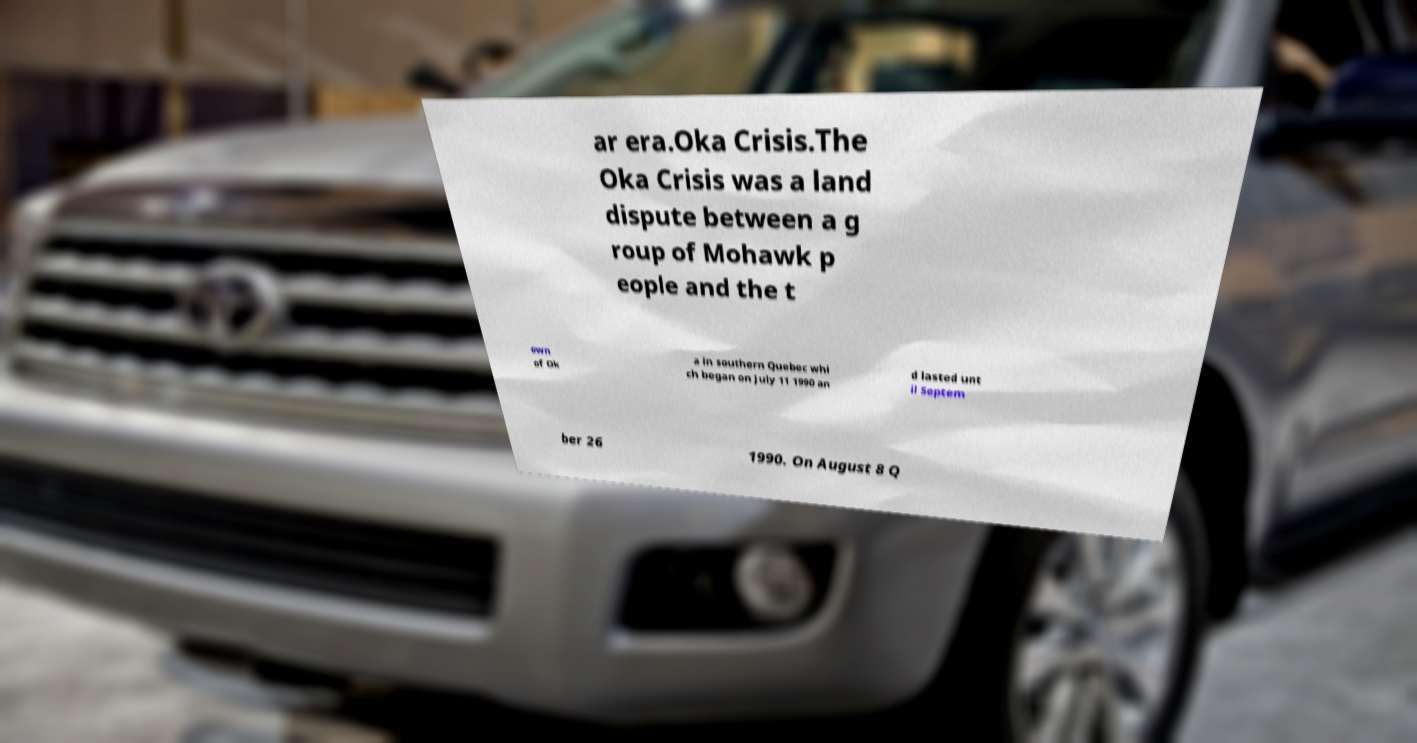Could you assist in decoding the text presented in this image and type it out clearly? ar era.Oka Crisis.The Oka Crisis was a land dispute between a g roup of Mohawk p eople and the t own of Ok a in southern Quebec whi ch began on July 11 1990 an d lasted unt il Septem ber 26 1990. On August 8 Q 